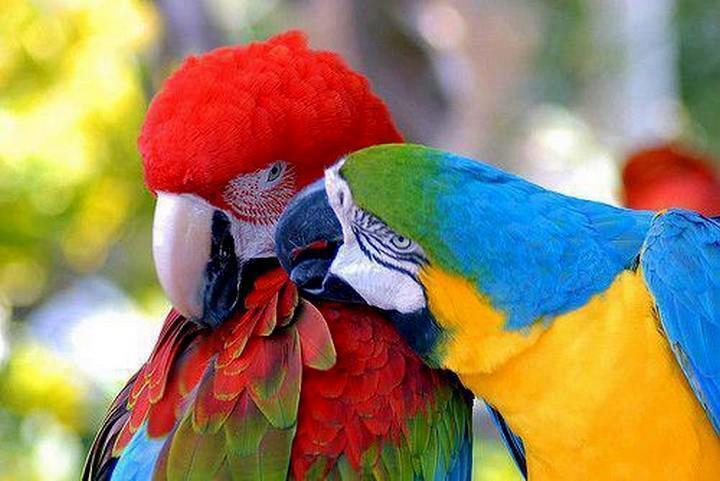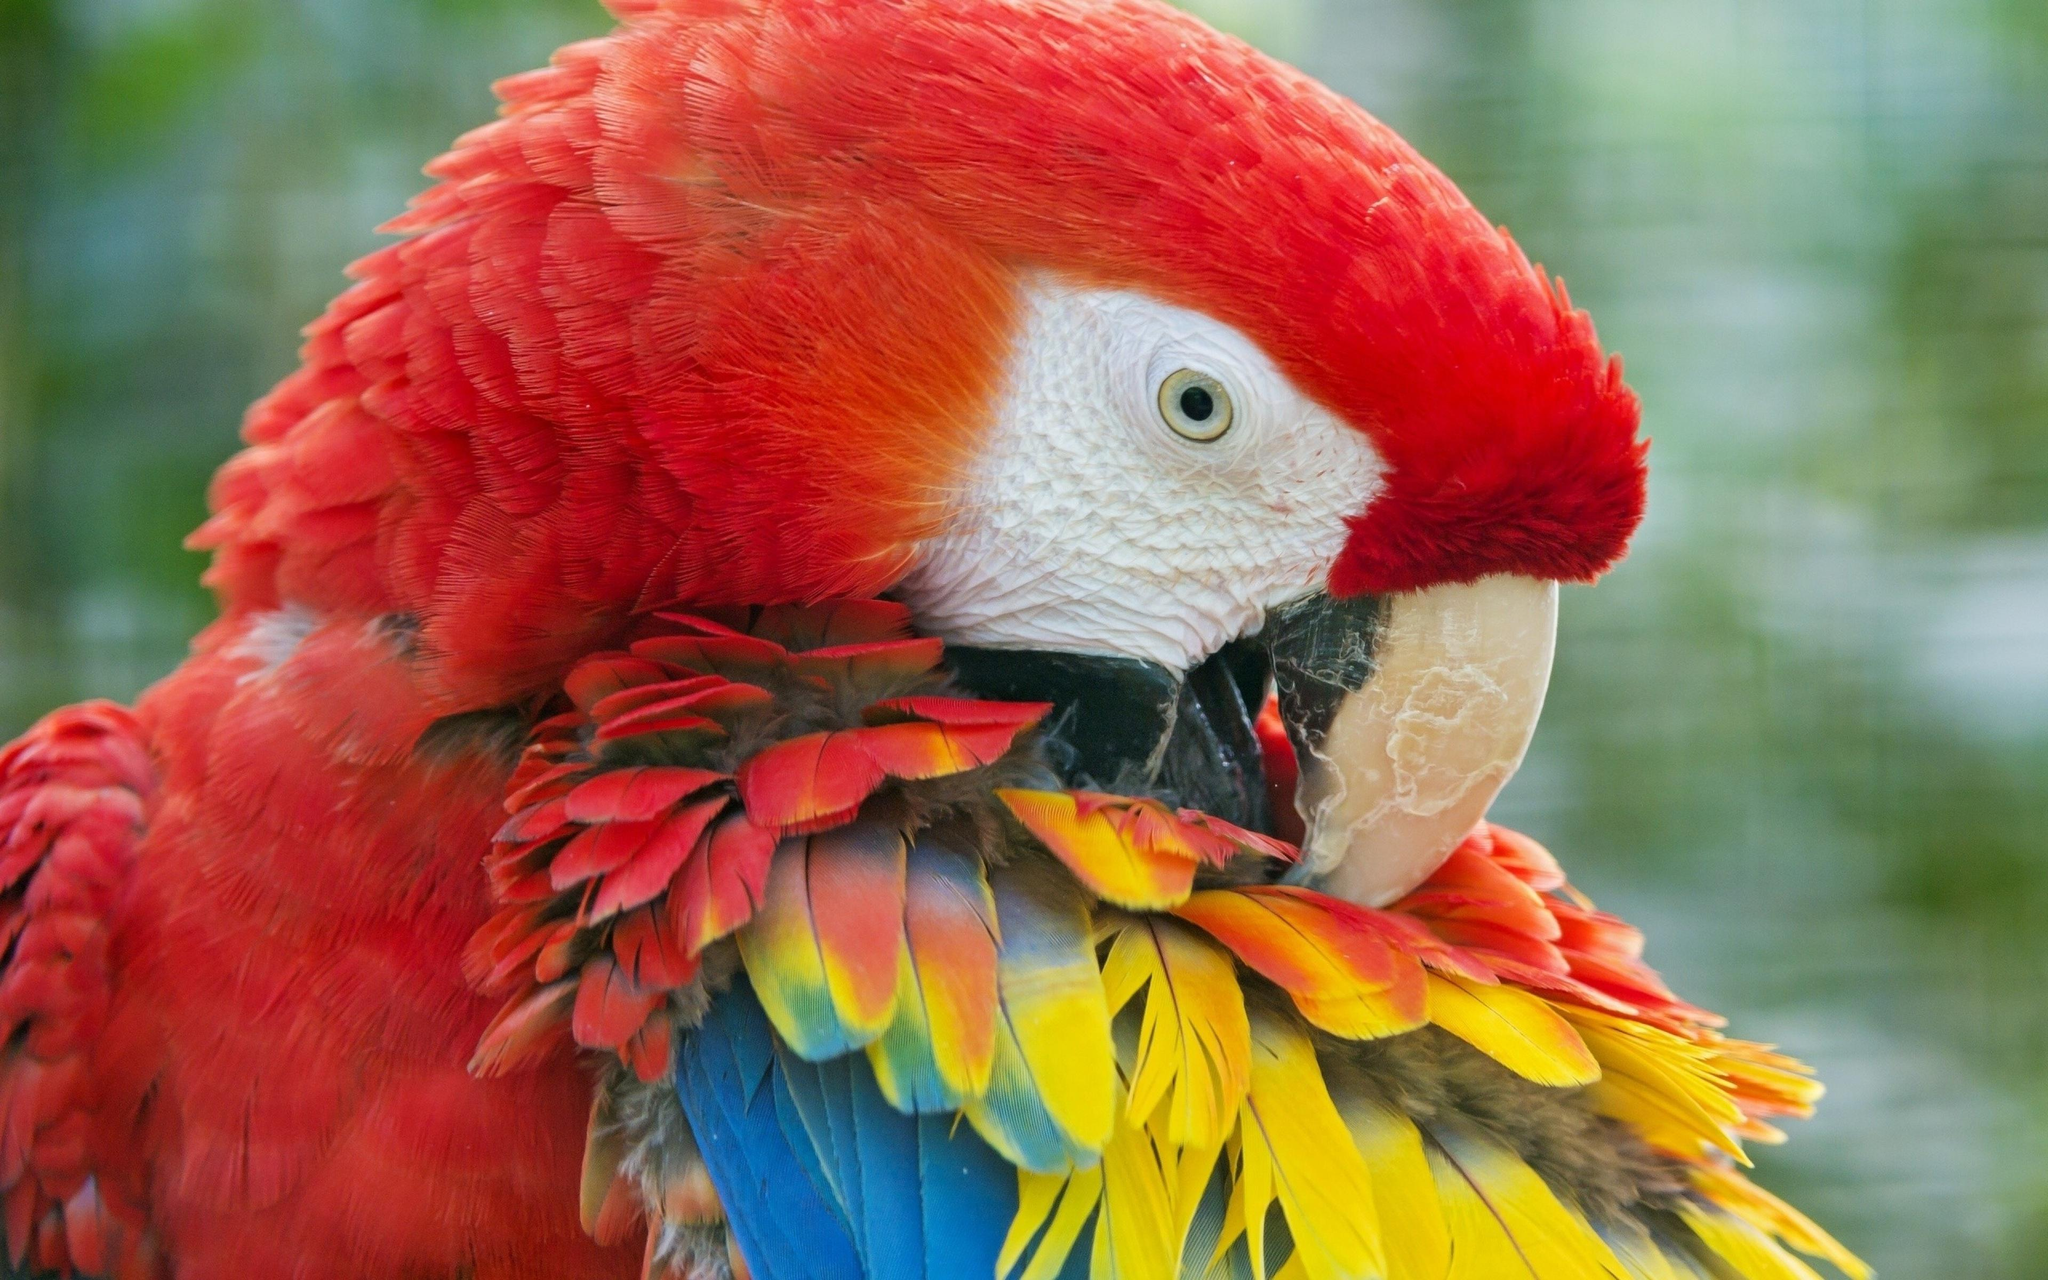The first image is the image on the left, the second image is the image on the right. Given the left and right images, does the statement "There are at most three scarlet macaws.." hold true? Answer yes or no. Yes. The first image is the image on the left, the second image is the image on the right. For the images displayed, is the sentence "The image on the right contains one parrot with blue wings closest to the left of the image." factually correct? Answer yes or no. No. 